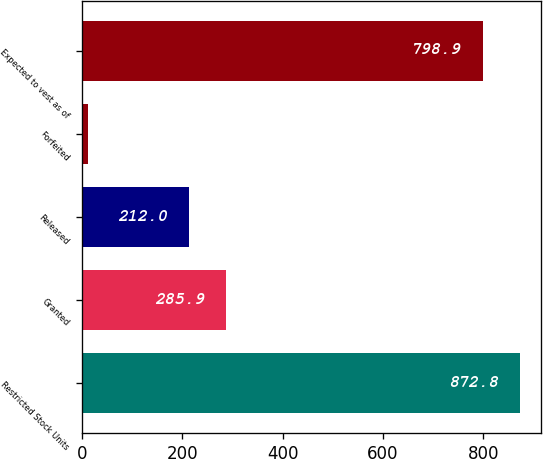Convert chart to OTSL. <chart><loc_0><loc_0><loc_500><loc_500><bar_chart><fcel>Restricted Stock Units<fcel>Granted<fcel>Released<fcel>Forfeited<fcel>Expected to vest as of<nl><fcel>872.8<fcel>285.9<fcel>212<fcel>11<fcel>798.9<nl></chart> 